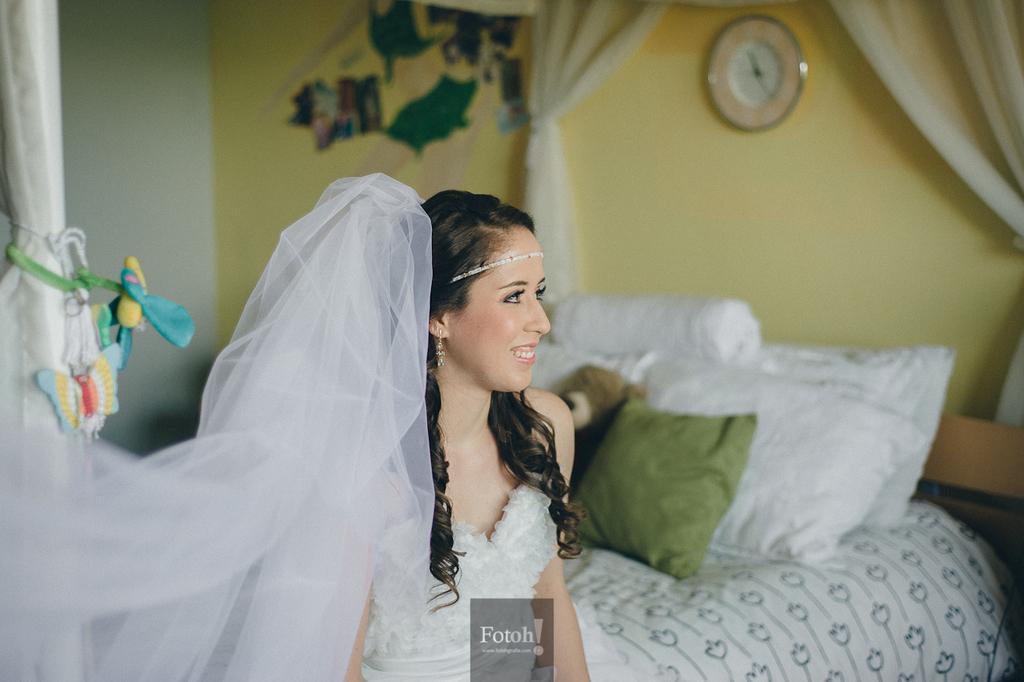How would you summarize this image in a sentence or two? In this image, there is a woman sitting on the bed on which cushions are kept white and green in color. The background wall is yellow in color on which wall clock is mounted and curtains are white in color and a wall painting is there on it. The image is taken inside a room. 